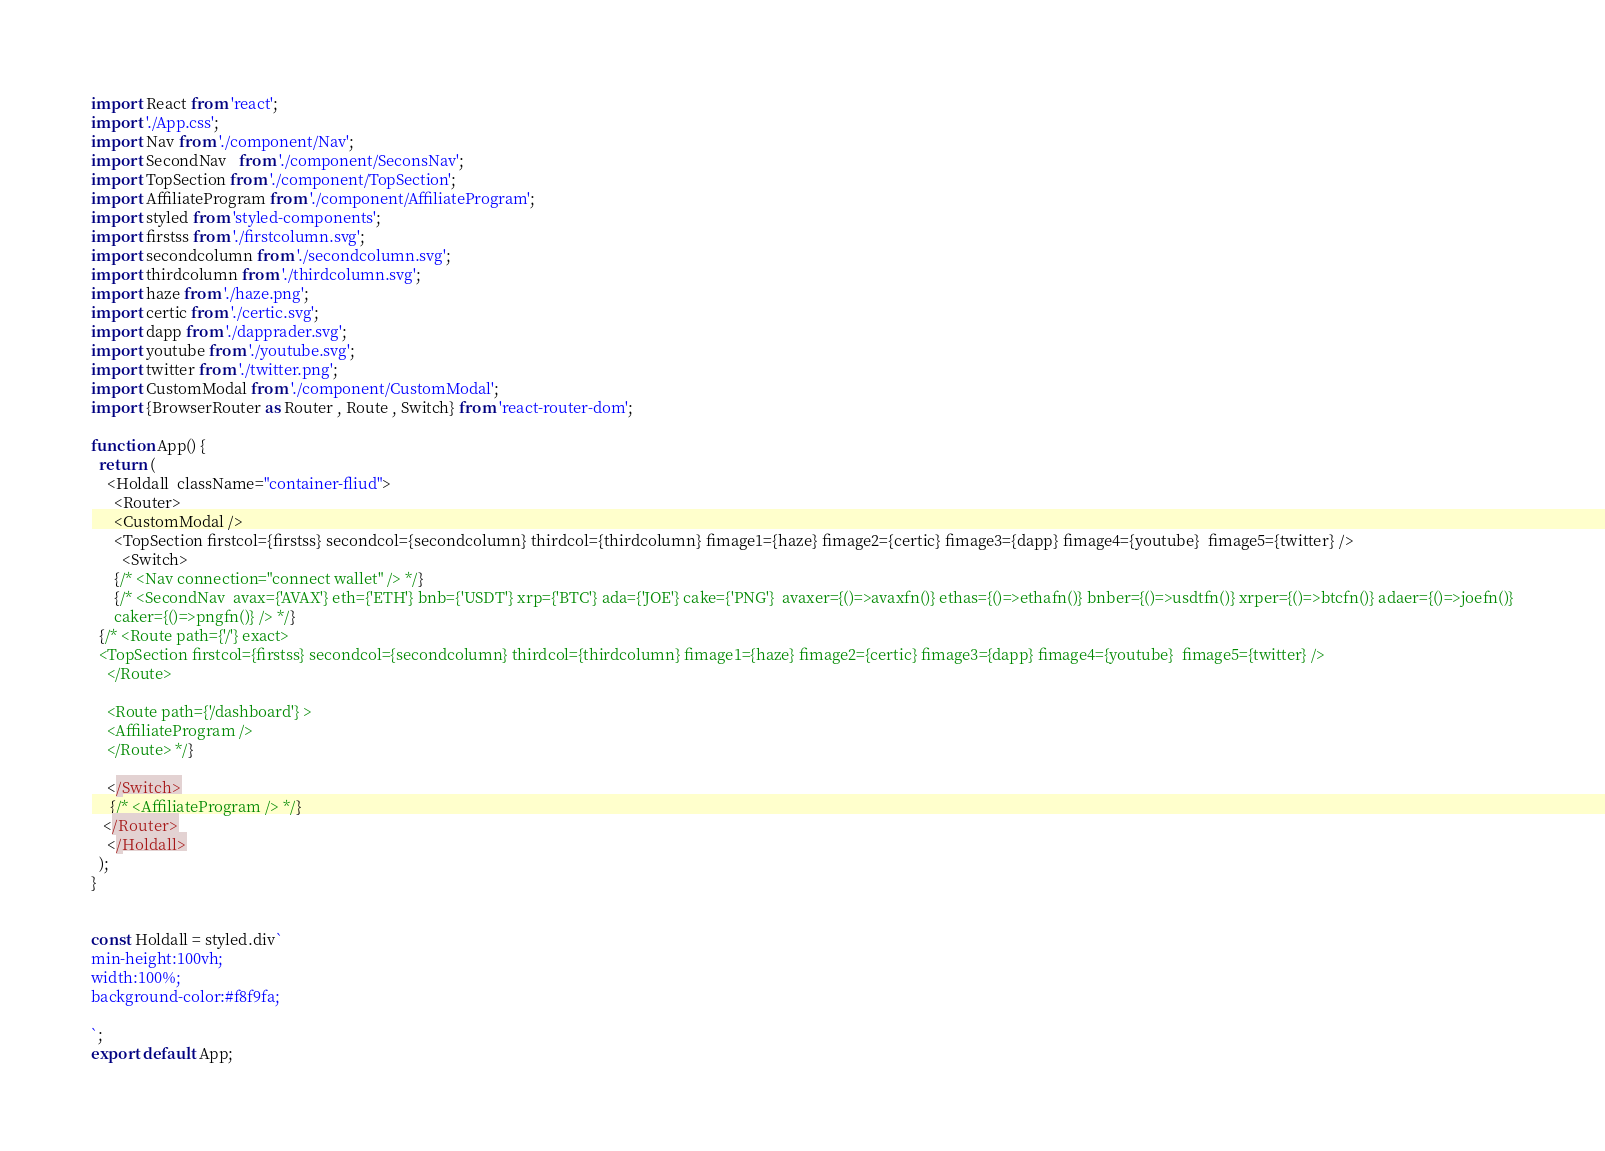<code> <loc_0><loc_0><loc_500><loc_500><_JavaScript_>import React from 'react';
import './App.css';
import Nav from './component/Nav';
import SecondNav   from './component/SeconsNav';
import TopSection from './component/TopSection';
import AffiliateProgram from './component/AffiliateProgram';
import styled from 'styled-components';
import firstss from './firstcolumn.svg';
import secondcolumn from './secondcolumn.svg';
import thirdcolumn from './thirdcolumn.svg';
import haze from './haze.png';
import certic from './certic.svg';
import dapp from './dapprader.svg';
import youtube from './youtube.svg';
import twitter from './twitter.png';
import CustomModal from './component/CustomModal';
import {BrowserRouter as Router , Route , Switch} from 'react-router-dom';

function App() {
  return (
    <Holdall  className="container-fliud">
      <Router>
      <CustomModal />
      <TopSection firstcol={firstss} secondcol={secondcolumn} thirdcol={thirdcolumn} fimage1={haze} fimage2={certic} fimage3={dapp} fimage4={youtube}  fimage5={twitter} /> 
        <Switch>
      {/* <Nav connection="connect wallet" /> */}
      {/* <SecondNav  avax={'AVAX'} eth={'ETH'} bnb={'USDT'} xrp={'BTC'} ada={'JOE'} cake={'PNG'}  avaxer={()=>avaxfn()} ethas={()=>ethafn()} bnber={()=>usdtfn()} xrper={()=>btcfn()} adaer={()=>joefn()}
      caker={()=>pngfn()} /> */}
  {/* <Route path={'/'} exact>
  <TopSection firstcol={firstss} secondcol={secondcolumn} thirdcol={thirdcolumn} fimage1={haze} fimage2={certic} fimage3={dapp} fimage4={youtube}  fimage5={twitter} /> 
    </Route>

    <Route path={'/dashboard'} >
    <AffiliateProgram />
    </Route> */}
    
    </Switch>
     {/* <AffiliateProgram /> */}
   </Router>
    </Holdall>
  );
}


const Holdall = styled.div`
min-height:100vh;
width:100%;
background-color:#f8f9fa;

`;
export default App;
</code> 